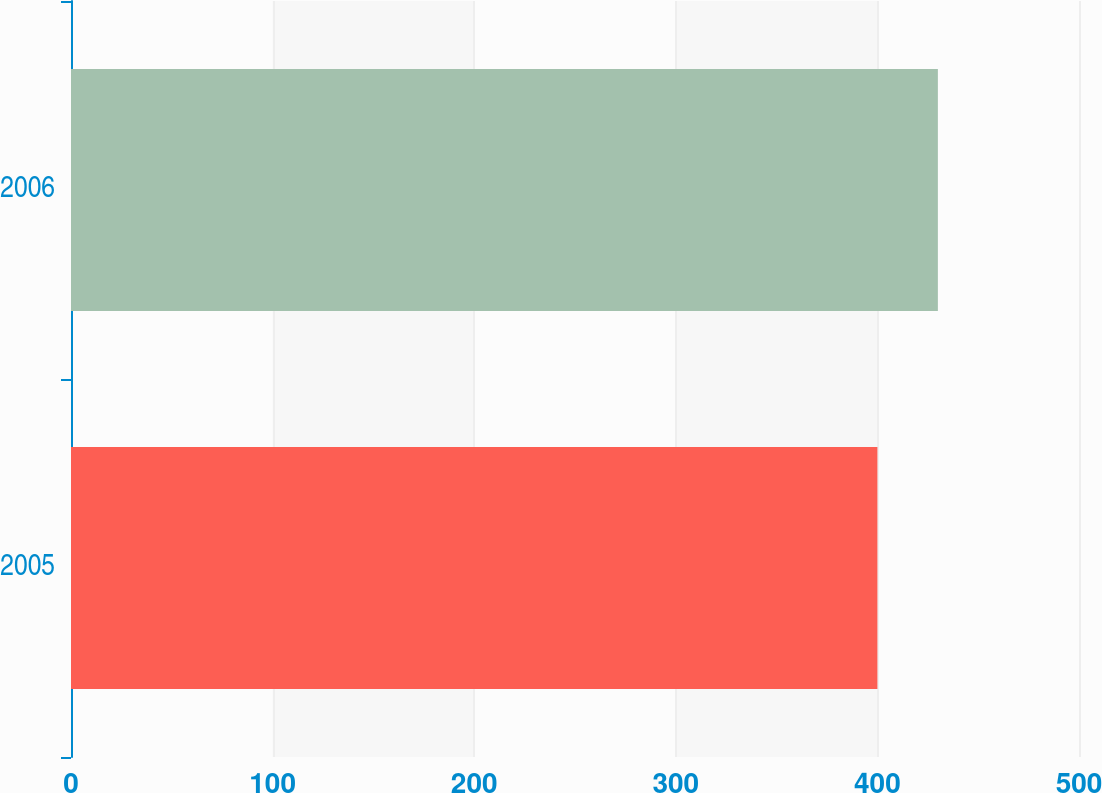Convert chart. <chart><loc_0><loc_0><loc_500><loc_500><bar_chart><fcel>2005<fcel>2006<nl><fcel>400<fcel>430<nl></chart> 